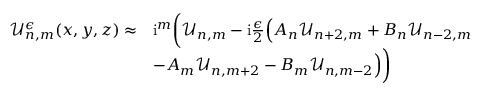<formula> <loc_0><loc_0><loc_500><loc_500>\begin{array} { r l } { \mathcal { U } _ { n , m } ^ { \epsilon } ( x , y , z ) \approx } & { i ^ { m } \left ( \mathcal { U } _ { n , m } - i \frac { \epsilon } { 2 } \left ( A _ { n } \mathcal { U } _ { n + 2 , m } + B _ { n } \mathcal { U } _ { n - 2 , m } } \\ & { - A _ { m } \mathcal { U } _ { n , m + 2 } - B _ { m } \mathcal { U } _ { n , m - 2 } \right ) \right ) } \end{array}</formula> 